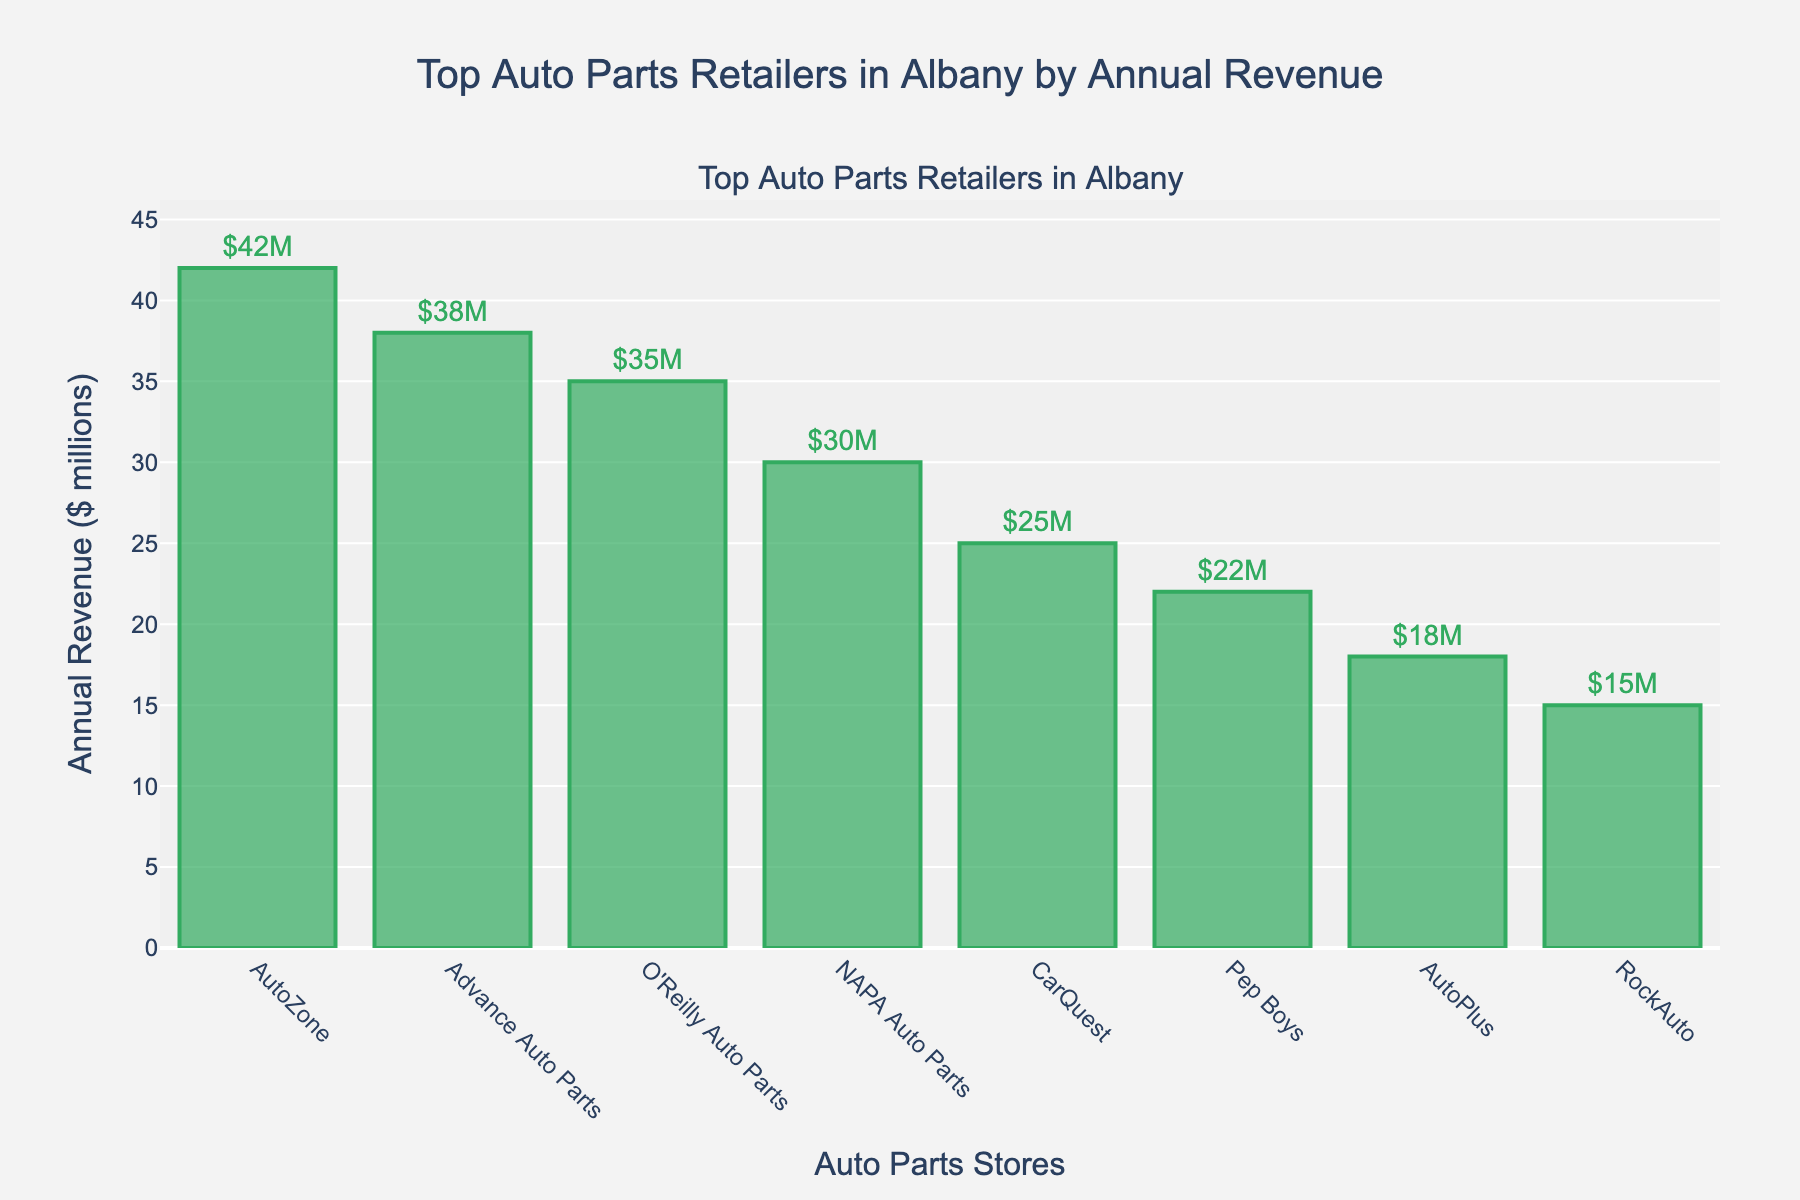Which store has the highest annual revenue? By looking at the heights of the bars, we identify that the tallest bar is for AutoZone which has the highest annual revenue.
Answer: AutoZone What is the combined annual revenue of O'Reilly Auto Parts and NAPA Auto Parts? The annual revenue of O'Reilly Auto Parts is $35 million and for NAPA Auto Parts is $30 million. Adding these together: $35M + $30M = $65M.
Answer: $65 million Which store has lower annual revenue, CarQuest, or Advance Auto Parts? By comparing the bar heights, CarQuest's bar is shorter than Advance Auto Parts', indicating CarQuest has lower annual revenue.
Answer: CarQuest How much more is the annual revenue of AutoZone compared to CarQuest? AutoZone has $42 million and CarQuest has $25 million. The difference is $42M - $25M = $17M.
Answer: $17 million Which stores have annual revenues below $30 million? Observing the heights of the bars that are below the $30M mark, the stores are CarQuest ($25M), Pep Boys ($22M), AutoPlus ($18M), and RockAuto ($15M).
Answer: CarQuest, Pep Boys, AutoPlus, RockAuto What is the average annual revenue of the top 3 stores? The top 3 stores are AutoZone ($42M), Advance Auto Parts ($38M), and O'Reilly Auto Parts ($35M). The sum is $42M + $38M + $35M = $115M. The average is $115M / 3 = $38.33M.
Answer: $38.33 million How many stores have an annual revenue higher than $30 million? By counting the bars whose height represents revenue above $30M, we find there are four such bars: AutoZone, Advance Auto Parts, O'Reilly Auto Parts, and NAPA Auto Parts.
Answer: 4 Is the annual revenue of NAPA Auto Parts closer to that of O'Reilly Auto Parts or Advance Auto Parts? NAPA Auto Parts has $30M. The difference with O'Reilly Auto Parts ($35M) is $5M. The difference with Advance Auto Parts ($38M) is $8M. Since $5M < $8M, it's closer to O'Reilly Auto Parts.
Answer: O'Reilly Auto Parts 